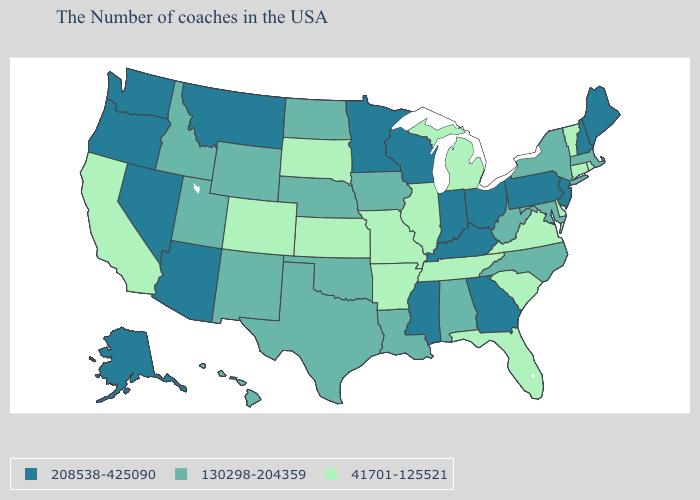Among the states that border Rhode Island , does Massachusetts have the lowest value?
Be succinct. No. What is the value of Nevada?
Short answer required. 208538-425090. What is the value of Nevada?
Concise answer only. 208538-425090. What is the lowest value in the USA?
Answer briefly. 41701-125521. What is the highest value in the USA?
Be succinct. 208538-425090. Name the states that have a value in the range 130298-204359?
Answer briefly. Massachusetts, New York, Maryland, North Carolina, West Virginia, Alabama, Louisiana, Iowa, Nebraska, Oklahoma, Texas, North Dakota, Wyoming, New Mexico, Utah, Idaho, Hawaii. Name the states that have a value in the range 208538-425090?
Concise answer only. Maine, New Hampshire, New Jersey, Pennsylvania, Ohio, Georgia, Kentucky, Indiana, Wisconsin, Mississippi, Minnesota, Montana, Arizona, Nevada, Washington, Oregon, Alaska. Name the states that have a value in the range 130298-204359?
Quick response, please. Massachusetts, New York, Maryland, North Carolina, West Virginia, Alabama, Louisiana, Iowa, Nebraska, Oklahoma, Texas, North Dakota, Wyoming, New Mexico, Utah, Idaho, Hawaii. Name the states that have a value in the range 130298-204359?
Write a very short answer. Massachusetts, New York, Maryland, North Carolina, West Virginia, Alabama, Louisiana, Iowa, Nebraska, Oklahoma, Texas, North Dakota, Wyoming, New Mexico, Utah, Idaho, Hawaii. What is the highest value in states that border Montana?
Give a very brief answer. 130298-204359. Does Rhode Island have the lowest value in the Northeast?
Give a very brief answer. Yes. Among the states that border Oklahoma , does Missouri have the lowest value?
Be succinct. Yes. Name the states that have a value in the range 208538-425090?
Write a very short answer. Maine, New Hampshire, New Jersey, Pennsylvania, Ohio, Georgia, Kentucky, Indiana, Wisconsin, Mississippi, Minnesota, Montana, Arizona, Nevada, Washington, Oregon, Alaska. What is the highest value in the USA?
Keep it brief. 208538-425090. What is the value of Indiana?
Short answer required. 208538-425090. 